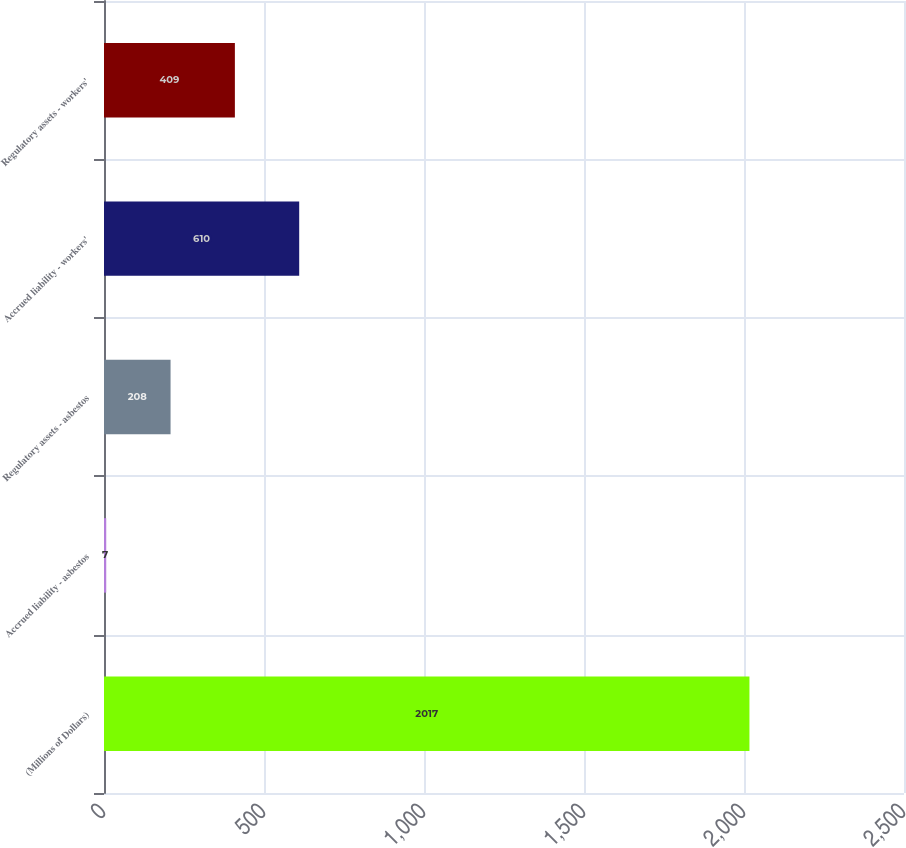Convert chart to OTSL. <chart><loc_0><loc_0><loc_500><loc_500><bar_chart><fcel>(Millions of Dollars)<fcel>Accrued liability - asbestos<fcel>Regulatory assets - asbestos<fcel>Accrued liability - workers'<fcel>Regulatory assets - workers'<nl><fcel>2017<fcel>7<fcel>208<fcel>610<fcel>409<nl></chart> 